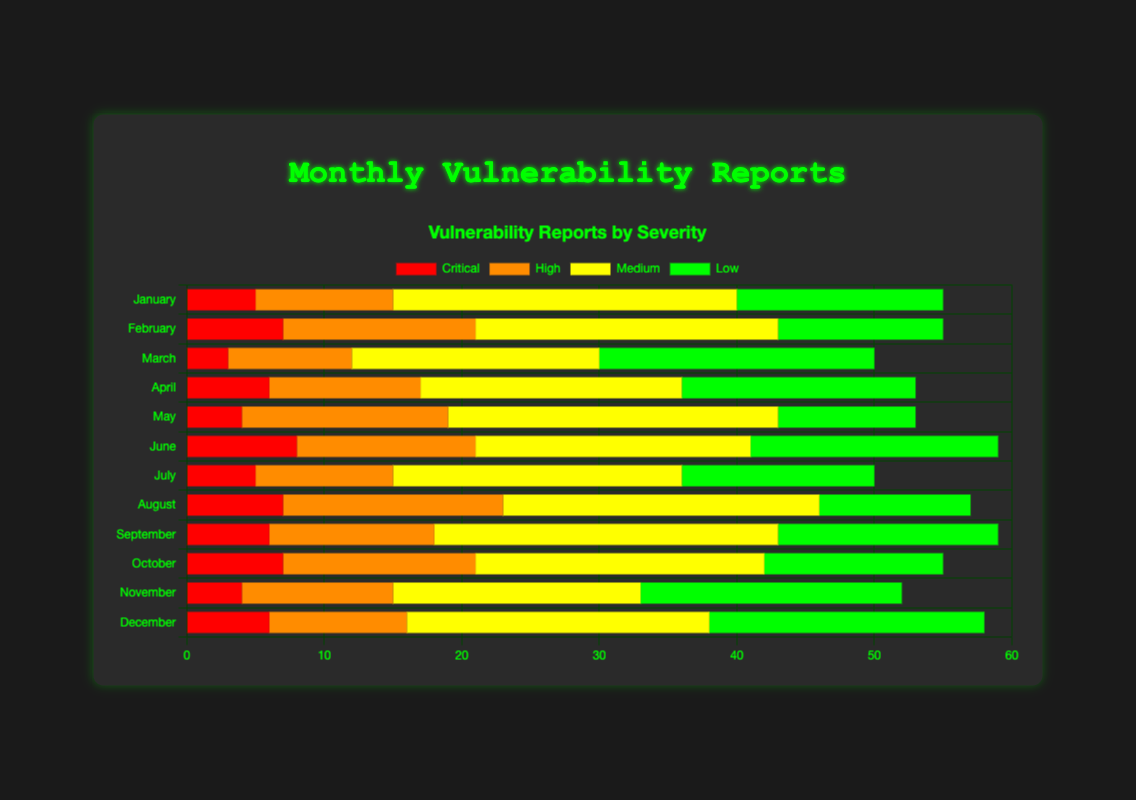Which month had the highest number of critical vulnerabilities reported? To find the month with the highest critical vulnerabilities, look at the "Critical" bar segment for each month and identify which is longest. February and October both have 7 critical vulnerabilities, the highest value.
Answer: February and October Comparing June and December, which month had fewer high vulnerabilities reported? Compare the "High" bar segments of June and December. June has 13 and December has 10 high vulnerabilities.
Answer: December What's the total number of vulnerabilities reported in May? Sum all vulnerability levels for May by adding the values of Low (10), Medium (24), High (15), and Critical (4): 10 + 24 + 15 + 4 = 53.
Answer: 53 What is the average number of medium vulnerabilities reported per month? Sum all medium vulnerabilities for each month and divide by the number of months. Total = 25+22+18+19+24+20+21+23+25+21+18+22 = 258. Average = 258/12 = 21.5.
Answer: 21.5 Which month had the smallest total number of vulnerabilities reported? Sum up all vulnerability levels for each month, then compare the totals. August has the smallest total: 11 (Low) + 23 (Medium) + 16 (High) + 7 (Critical) = 57.
Answer: August Between March and November, which month had more low vulnerabilities? Compare the "Low" bar segments of March and November. March has 20 low vulnerabilities and November has 19.
Answer: March What is the combined number of low and medium vulnerabilities reported in April? Add the low and medium vulnerabilities for April: 17 (Low) + 19 (Medium) = 36.
Answer: 36 What are the visual colors used to represent each severity level? Identify the colors used in the legend for each severity level. Critical is red, High is orange, Medium is yellow, and Low is green.
Answer: Red for Critical, Orange for High, Yellow for Medium, Green for Low Which severity level had the most consistent number of reports each month? Look at each severity level’s bar segment across all months to see which has the least variation. Medium vulnerabilities appear the most consistent, ranging between 18 and 25 each month.
Answer: Medium What is the difference in high vulnerabilities reported between the months with the highest and lowest values? Identify the months with the highest (May = 15) and lowest (March = 9) high vulnerabilities and calculate the difference: 15 - 9 = 6.
Answer: 6 